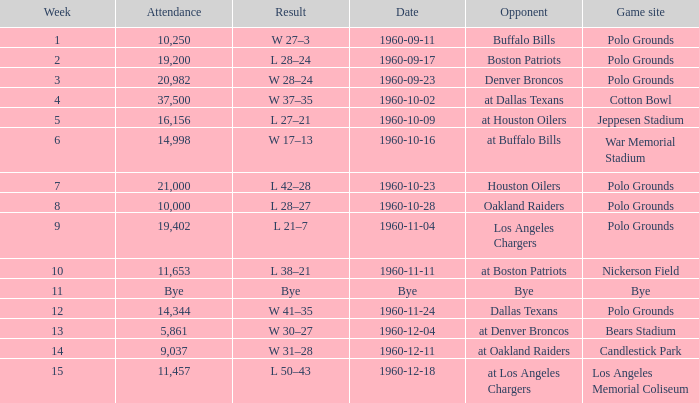What day did they play at candlestick park? 1960-12-11. 